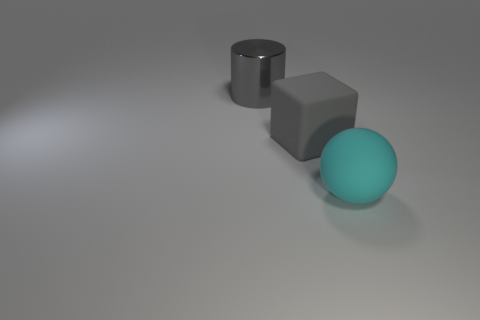Are the big cyan thing and the cylinder made of the same material? no 